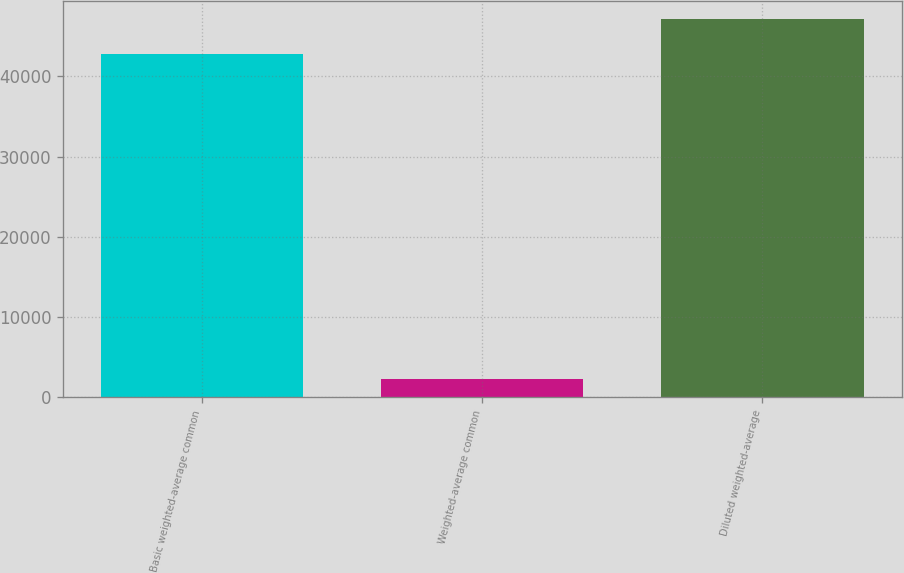<chart> <loc_0><loc_0><loc_500><loc_500><bar_chart><fcel>Basic weighted-average common<fcel>Weighted-average common<fcel>Diluted weighted-average<nl><fcel>42824<fcel>2302<fcel>47106.4<nl></chart> 